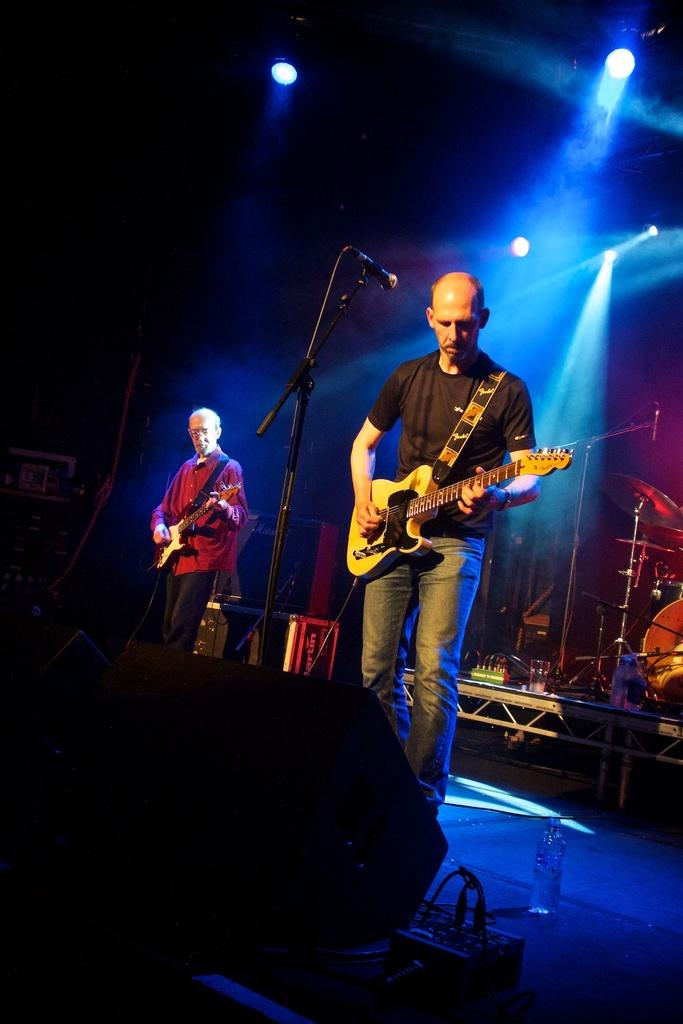What can be seen in the image? There are men in the image. Where are the men located? The men are standing on a stage. What are the men holding in their hands? The men are holding guitars in their hands. What type of soda is being served to the men on stage? There is no soda present in the image; the men are holding guitars. How many slaves are visible in the image? There are no slaves present in the image; the men are musicians on a stage. 